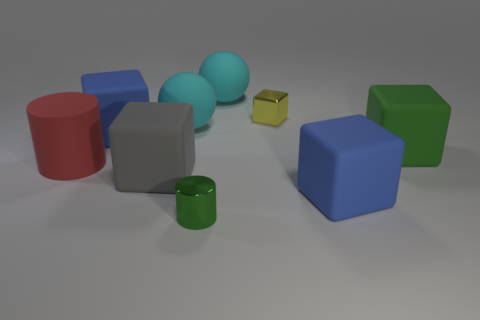Subtract all gray cubes. How many cubes are left? 4 Subtract all yellow blocks. How many blocks are left? 4 Add 1 tiny green shiny cylinders. How many objects exist? 10 Subtract all cyan blocks. Subtract all green cylinders. How many blocks are left? 5 Subtract all spheres. How many objects are left? 7 Subtract all large rubber cylinders. Subtract all yellow cubes. How many objects are left? 7 Add 5 tiny green objects. How many tiny green objects are left? 6 Add 1 green matte cubes. How many green matte cubes exist? 2 Subtract 0 purple cylinders. How many objects are left? 9 